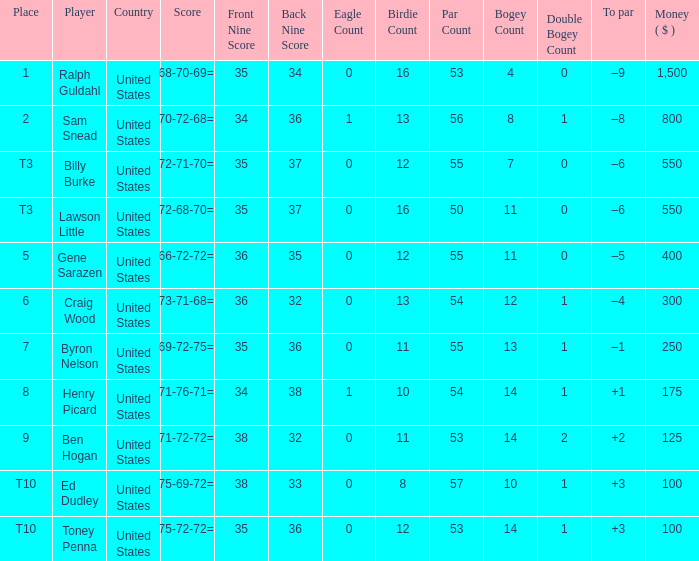Which country has a prize smaller than $250 and the player Henry Picard? United States. 